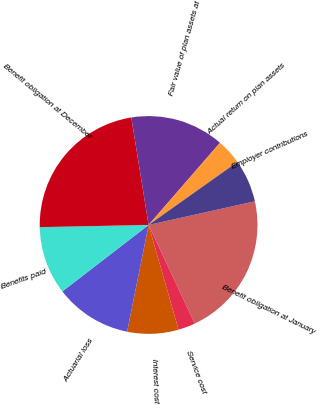<chart> <loc_0><loc_0><loc_500><loc_500><pie_chart><fcel>Benefit obligation at January<fcel>Service cost<fcel>Interest cost<fcel>Actuarial loss<fcel>Benefits paid<fcel>Benefit obligation at December<fcel>Fair value of plan assets at<fcel>Actual return on plan assets<fcel>Employer contributions<nl><fcel>21.52%<fcel>2.53%<fcel>7.6%<fcel>11.39%<fcel>10.13%<fcel>22.78%<fcel>13.92%<fcel>3.8%<fcel>6.33%<nl></chart> 